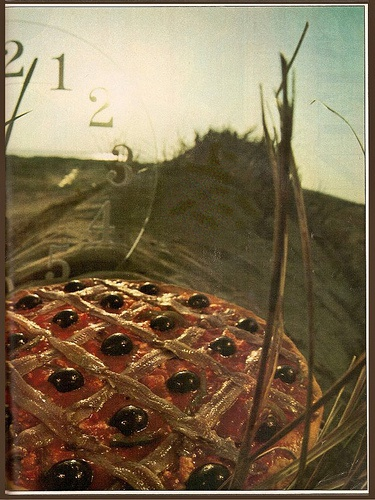Describe the objects in this image and their specific colors. I can see pizza in maroon, black, and brown tones and clock in maroon, olive, beige, and black tones in this image. 